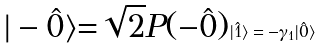Convert formula to latex. <formula><loc_0><loc_0><loc_500><loc_500>\text {$| - \hat{0} \rangle$=$\sqrt{2} P (- \hat{0})$} | \hat { 1 } \rangle = - \gamma _ { 1 } | \hat { 0 } \rangle</formula> 